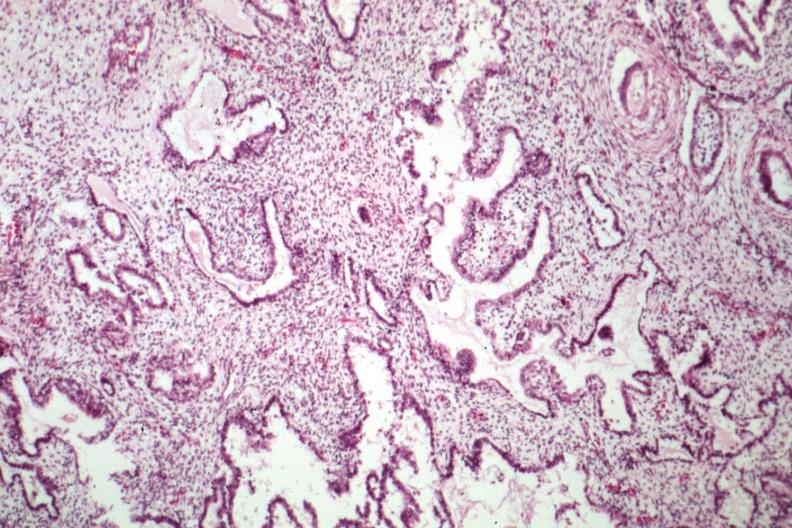s nodular tumor present?
Answer the question using a single word or phrase. No 